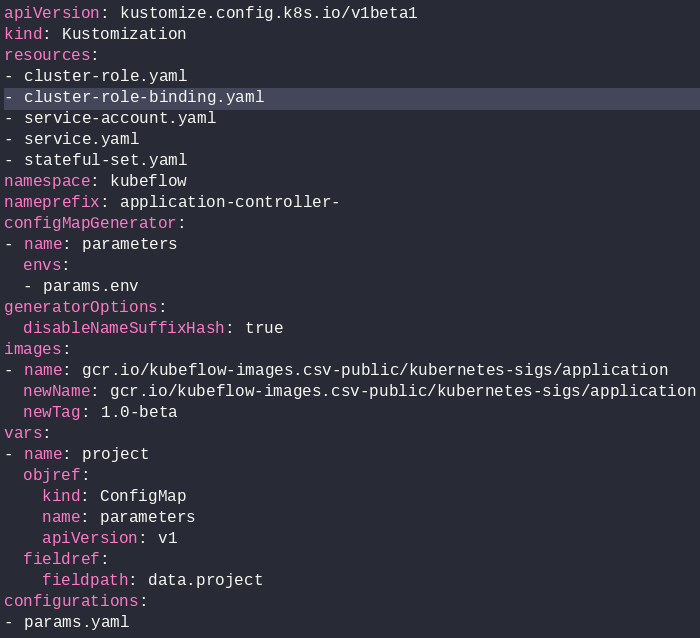Convert code to text. <code><loc_0><loc_0><loc_500><loc_500><_YAML_>apiVersion: kustomize.config.k8s.io/v1beta1
kind: Kustomization
resources:
- cluster-role.yaml
- cluster-role-binding.yaml
- service-account.yaml
- service.yaml
- stateful-set.yaml
namespace: kubeflow
nameprefix: application-controller-
configMapGenerator:
- name: parameters
  envs:
  - params.env
generatorOptions:
  disableNameSuffixHash: true
images:
- name: gcr.io/kubeflow-images.csv-public/kubernetes-sigs/application
  newName: gcr.io/kubeflow-images.csv-public/kubernetes-sigs/application
  newTag: 1.0-beta
vars:
- name: project
  objref:
    kind: ConfigMap
    name: parameters
    apiVersion: v1
  fieldref:
    fieldpath: data.project
configurations:
- params.yaml
</code> 